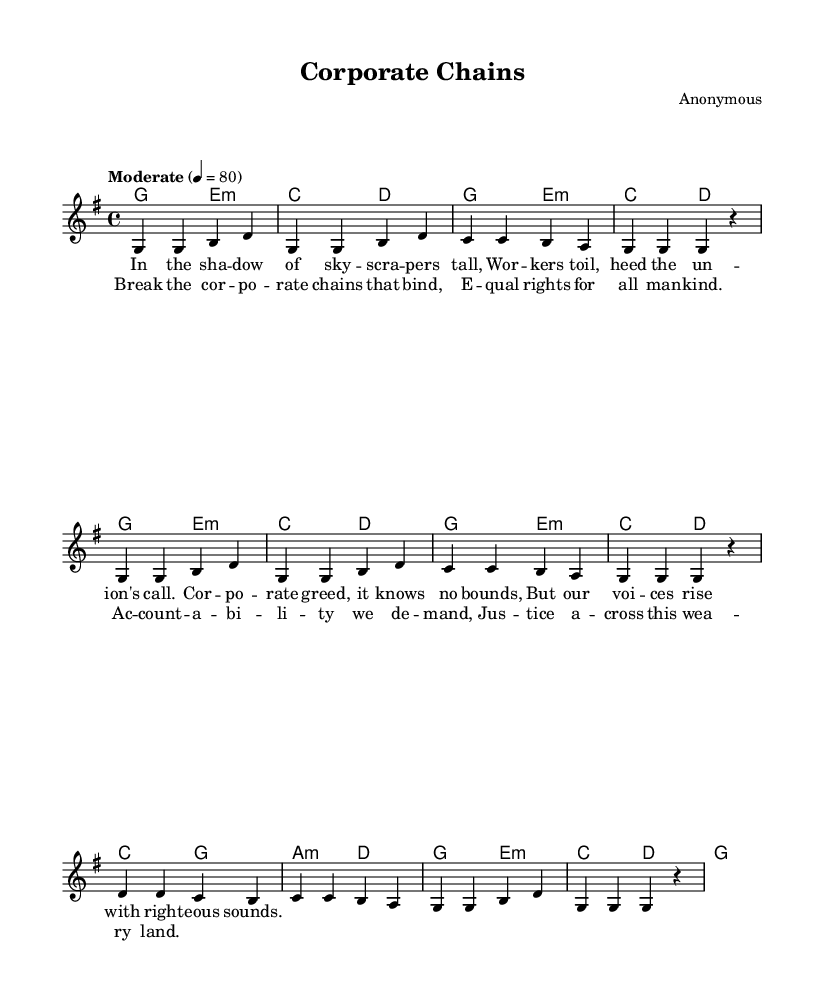What is the key signature of this music? The key signature is G major, which has one sharp (F#). This can be identified by looking at the key signature section located at the beginning of the staff, where a sharp is placed on the F line.
Answer: G major What is the time signature of this music? The time signature is 4/4, indicated at the beginning of the score. This means there are four beats in each measure, and the quarter note gets one beat.
Answer: 4/4 What is the tempo marking for this piece? The tempo marking is "Moderate," followed by a metronome marking of 80 beats per minute. This indicates a moderate speed for the performance of the piece.
Answer: Moderate How many measures are in the melody? There are 8 measures in the melody. This can be counted by observing the bar lines that separate each measure.
Answer: 8 What do the lyrics describe in the first verse? The lyrics in the first verse describe workers responding to the union's call in the struggle against corporate greed. They emphasize the importance of unity among workers against exploitation.
Answer: Workers' unity against corporate greed What is the theme of the chorus? The theme of the chorus is advocating for equality and accountability while calling for justice across the land. It emphasizes breaking corporate chains and demanding equal rights.
Answer: Equality and accountability What type of song is this considered? This song is considered a labor rights folk song. Labor rights songs often focus on social justice, workers' rights, and corporate accountability, aligning with the content of this piece.
Answer: Labor rights folk song 